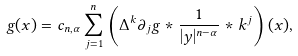Convert formula to latex. <formula><loc_0><loc_0><loc_500><loc_500>g ( x ) = c _ { n , \alpha } \sum _ { j = 1 } ^ { n } \left ( \Delta ^ { k } \partial _ { j } g * \frac { 1 } { | y | ^ { n - \alpha } } * k ^ { j } \right ) ( x ) ,</formula> 